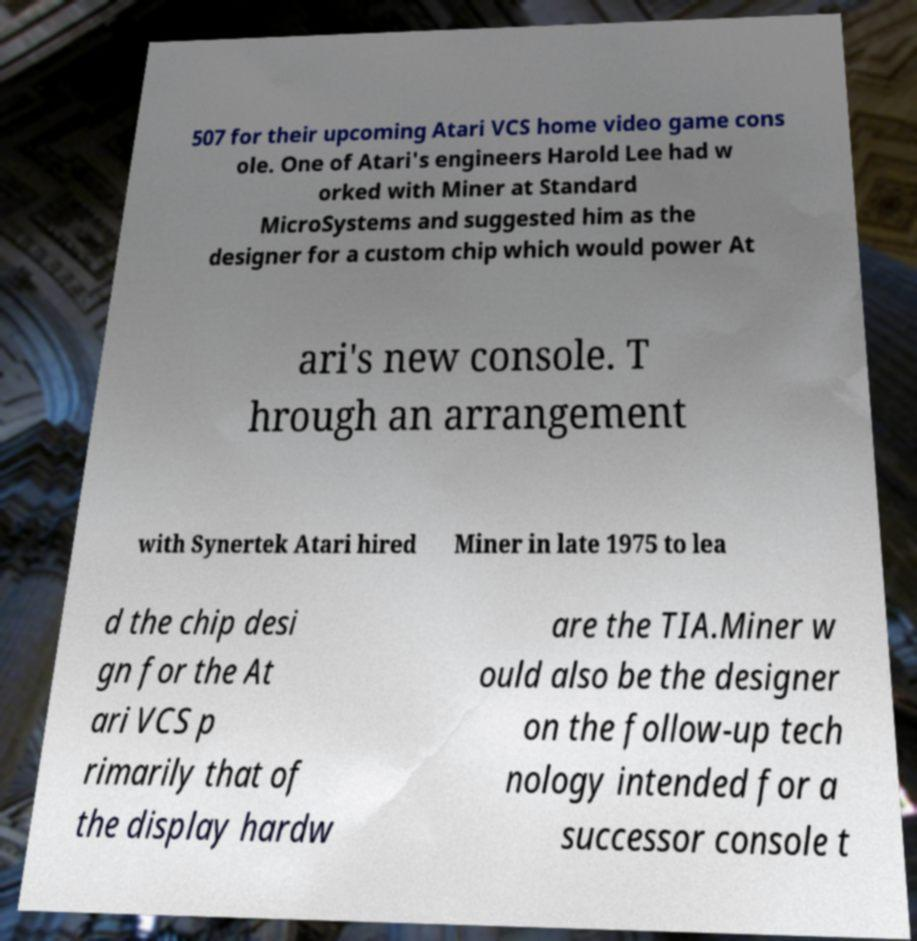Can you accurately transcribe the text from the provided image for me? 507 for their upcoming Atari VCS home video game cons ole. One of Atari's engineers Harold Lee had w orked with Miner at Standard MicroSystems and suggested him as the designer for a custom chip which would power At ari's new console. T hrough an arrangement with Synertek Atari hired Miner in late 1975 to lea d the chip desi gn for the At ari VCS p rimarily that of the display hardw are the TIA.Miner w ould also be the designer on the follow-up tech nology intended for a successor console t 